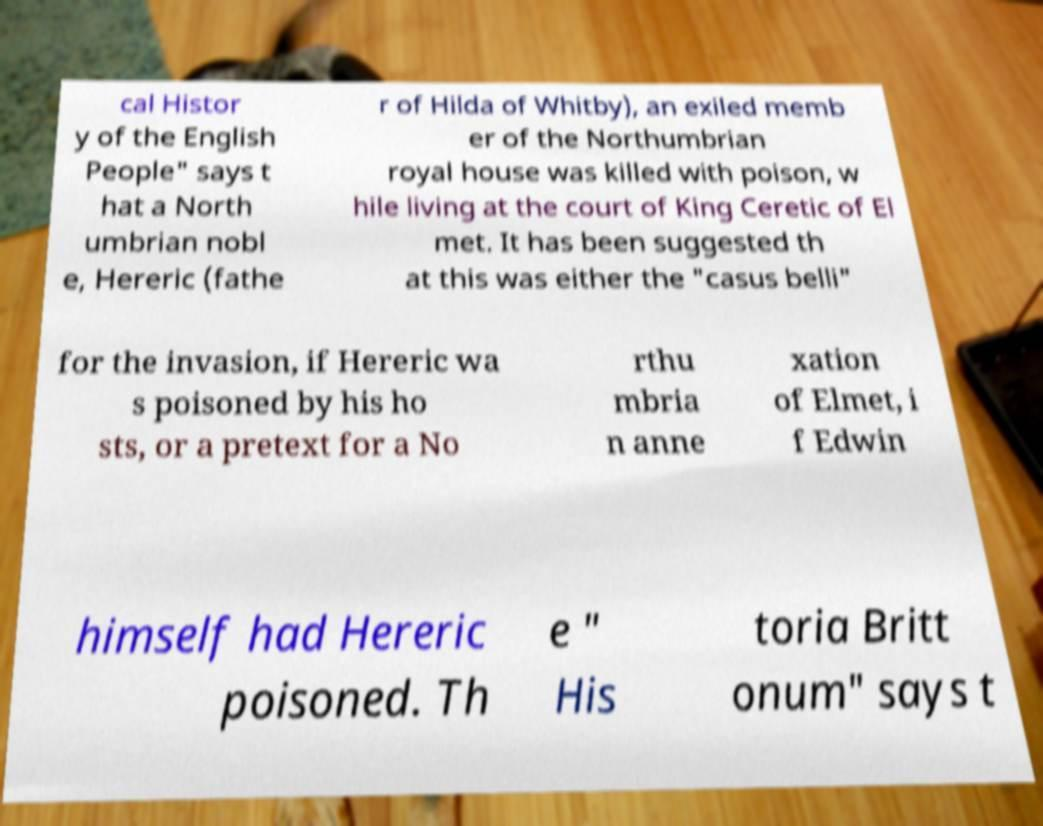Could you extract and type out the text from this image? cal Histor y of the English People" says t hat a North umbrian nobl e, Hereric (fathe r of Hilda of Whitby), an exiled memb er of the Northumbrian royal house was killed with poison, w hile living at the court of King Ceretic of El met. It has been suggested th at this was either the "casus belli" for the invasion, if Hereric wa s poisoned by his ho sts, or a pretext for a No rthu mbria n anne xation of Elmet, i f Edwin himself had Hereric poisoned. Th e " His toria Britt onum" says t 